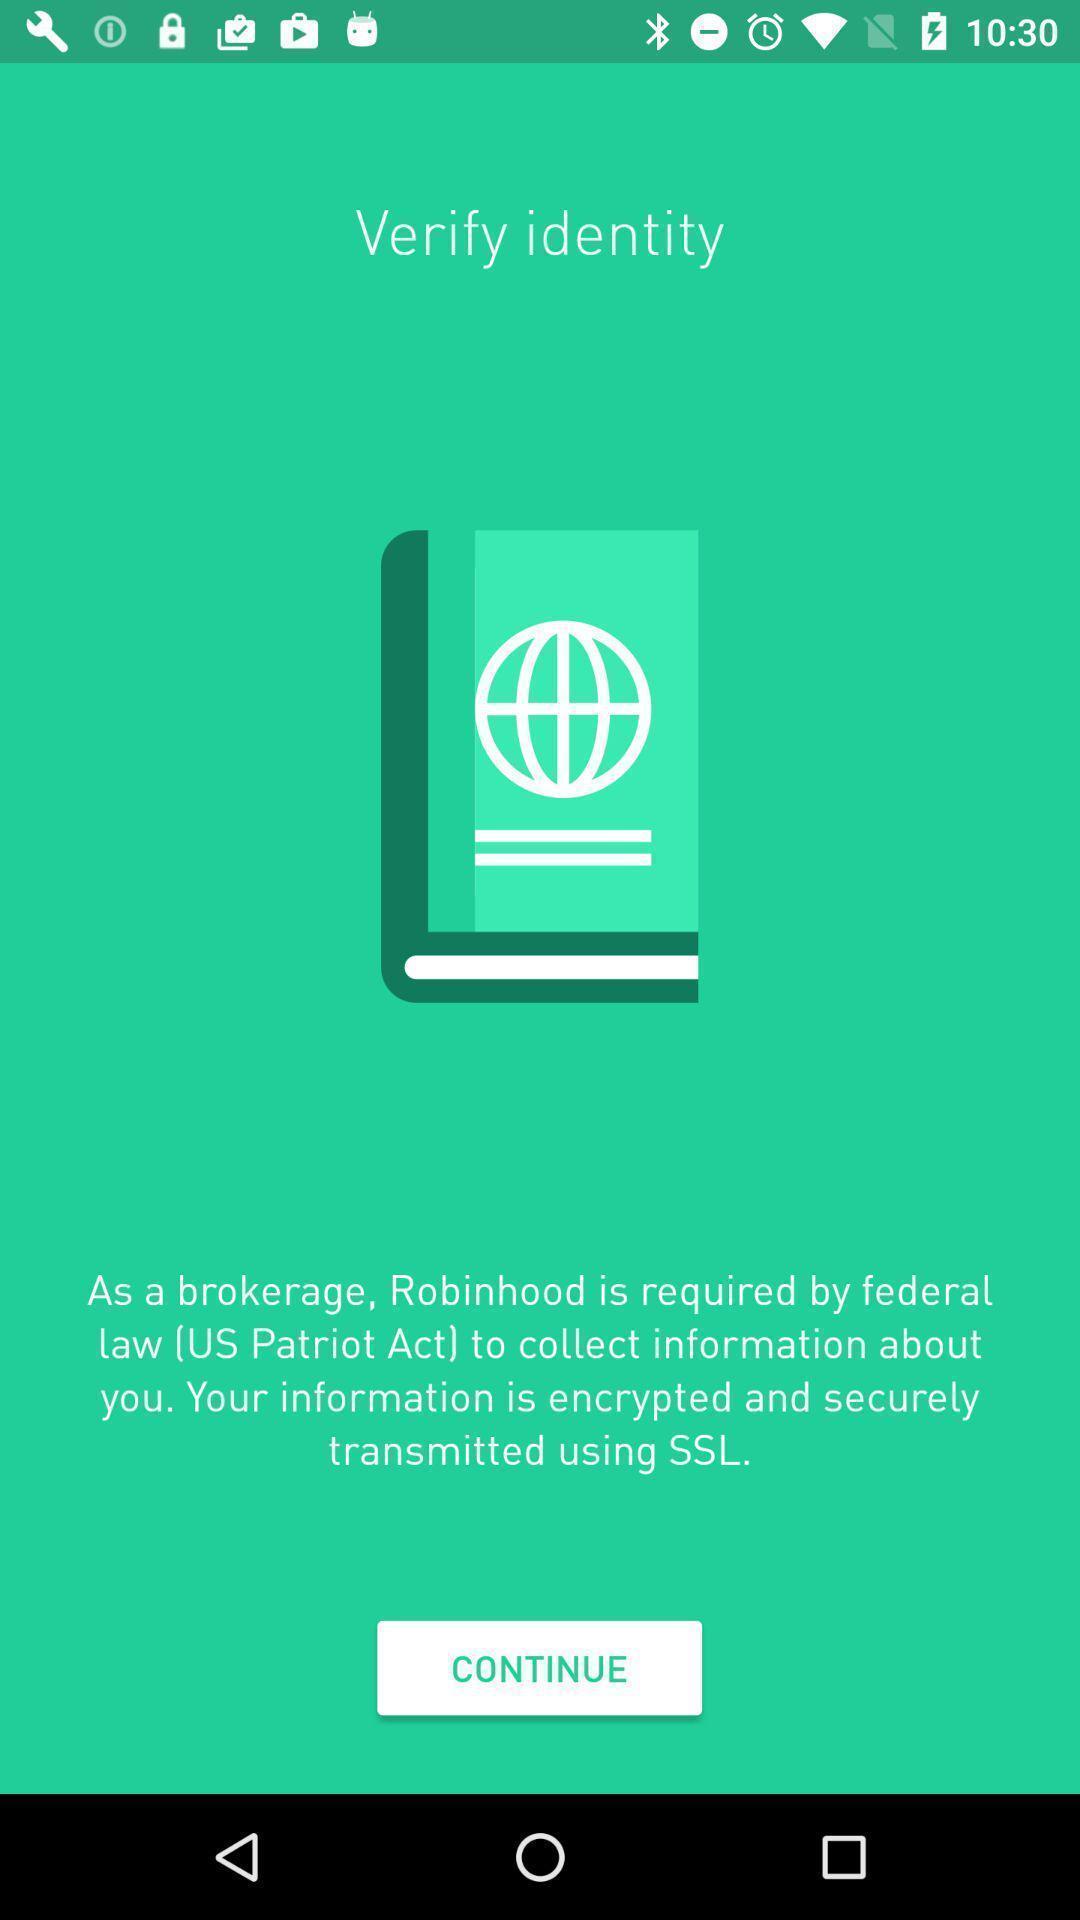Summarize the main components in this picture. Screen page displaying to continue an application. 